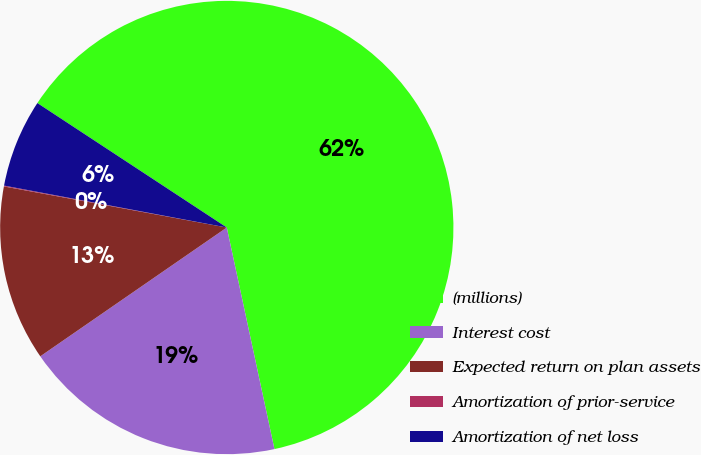Convert chart. <chart><loc_0><loc_0><loc_500><loc_500><pie_chart><fcel>(millions)<fcel>Interest cost<fcel>Expected return on plan assets<fcel>Amortization of prior-service<fcel>Amortization of net loss<nl><fcel>62.37%<fcel>18.75%<fcel>12.52%<fcel>0.06%<fcel>6.29%<nl></chart> 